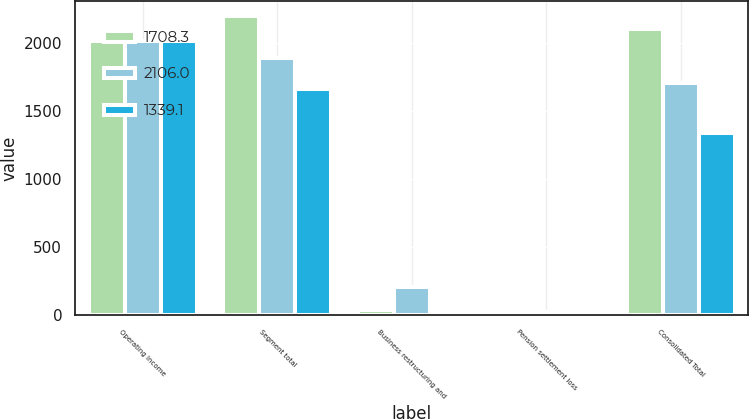<chart> <loc_0><loc_0><loc_500><loc_500><stacked_bar_chart><ecel><fcel>Operating Income<fcel>Segment total<fcel>Business restructuring and<fcel>Pension settlement loss<fcel>Consolidated Total<nl><fcel>1708.3<fcel>2016<fcel>2198.5<fcel>33.9<fcel>6.4<fcel>2106<nl><fcel>2106<fcel>2015<fcel>1893.2<fcel>207.7<fcel>21.2<fcel>1708.3<nl><fcel>1339.1<fcel>2014<fcel>1667.4<fcel>12.7<fcel>5.5<fcel>1339.1<nl></chart> 